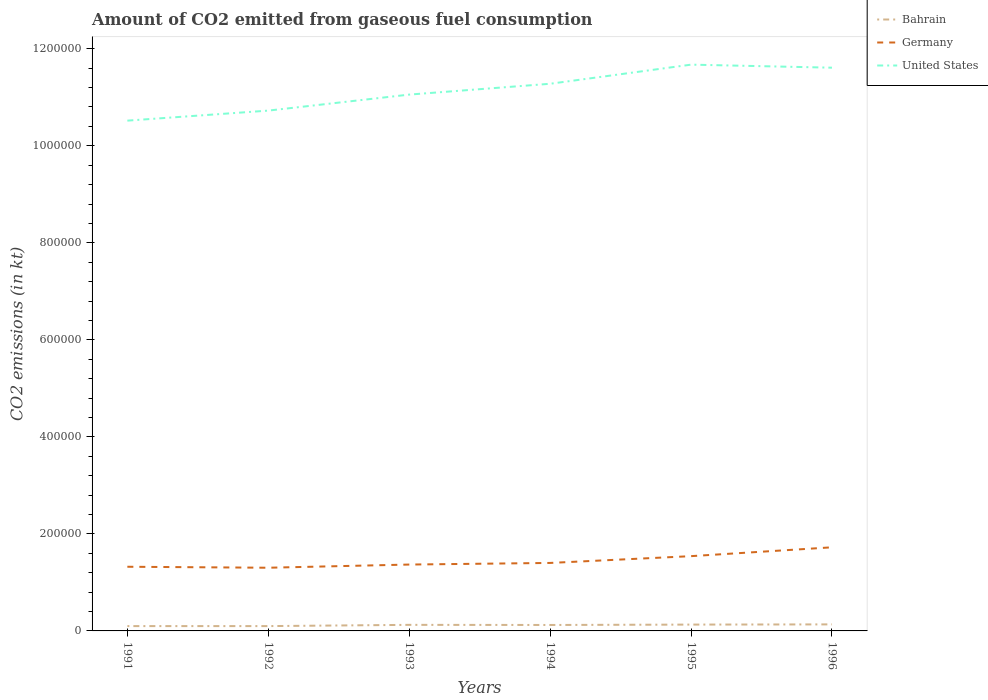Does the line corresponding to Bahrain intersect with the line corresponding to United States?
Offer a terse response. No. Is the number of lines equal to the number of legend labels?
Make the answer very short. Yes. Across all years, what is the maximum amount of CO2 emitted in Germany?
Ensure brevity in your answer.  1.30e+05. In which year was the amount of CO2 emitted in Germany maximum?
Provide a succinct answer. 1992. What is the total amount of CO2 emitted in Germany in the graph?
Make the answer very short. -1.82e+04. What is the difference between the highest and the second highest amount of CO2 emitted in Bahrain?
Provide a succinct answer. 3520.32. What is the difference between two consecutive major ticks on the Y-axis?
Offer a terse response. 2.00e+05. Are the values on the major ticks of Y-axis written in scientific E-notation?
Offer a very short reply. No. Does the graph contain any zero values?
Provide a short and direct response. No. How many legend labels are there?
Give a very brief answer. 3. How are the legend labels stacked?
Your answer should be very brief. Vertical. What is the title of the graph?
Offer a very short reply. Amount of CO2 emitted from gaseous fuel consumption. What is the label or title of the X-axis?
Give a very brief answer. Years. What is the label or title of the Y-axis?
Give a very brief answer. CO2 emissions (in kt). What is the CO2 emissions (in kt) of Bahrain in 1991?
Make the answer very short. 9944.9. What is the CO2 emissions (in kt) in Germany in 1991?
Your answer should be very brief. 1.32e+05. What is the CO2 emissions (in kt) in United States in 1991?
Your response must be concise. 1.05e+06. What is the CO2 emissions (in kt) of Bahrain in 1992?
Ensure brevity in your answer.  9944.9. What is the CO2 emissions (in kt) in Germany in 1992?
Make the answer very short. 1.30e+05. What is the CO2 emissions (in kt) in United States in 1992?
Ensure brevity in your answer.  1.07e+06. What is the CO2 emissions (in kt) in Bahrain in 1993?
Offer a terse response. 1.25e+04. What is the CO2 emissions (in kt) of Germany in 1993?
Your answer should be very brief. 1.37e+05. What is the CO2 emissions (in kt) in United States in 1993?
Give a very brief answer. 1.11e+06. What is the CO2 emissions (in kt) in Bahrain in 1994?
Your answer should be very brief. 1.23e+04. What is the CO2 emissions (in kt) in Germany in 1994?
Provide a succinct answer. 1.40e+05. What is the CO2 emissions (in kt) of United States in 1994?
Make the answer very short. 1.13e+06. What is the CO2 emissions (in kt) in Bahrain in 1995?
Offer a very short reply. 1.31e+04. What is the CO2 emissions (in kt) in Germany in 1995?
Your response must be concise. 1.54e+05. What is the CO2 emissions (in kt) in United States in 1995?
Provide a short and direct response. 1.17e+06. What is the CO2 emissions (in kt) in Bahrain in 1996?
Provide a short and direct response. 1.35e+04. What is the CO2 emissions (in kt) of Germany in 1996?
Your answer should be compact. 1.72e+05. What is the CO2 emissions (in kt) of United States in 1996?
Provide a short and direct response. 1.16e+06. Across all years, what is the maximum CO2 emissions (in kt) of Bahrain?
Your answer should be compact. 1.35e+04. Across all years, what is the maximum CO2 emissions (in kt) in Germany?
Make the answer very short. 1.72e+05. Across all years, what is the maximum CO2 emissions (in kt) in United States?
Your answer should be compact. 1.17e+06. Across all years, what is the minimum CO2 emissions (in kt) in Bahrain?
Offer a very short reply. 9944.9. Across all years, what is the minimum CO2 emissions (in kt) in Germany?
Keep it short and to the point. 1.30e+05. Across all years, what is the minimum CO2 emissions (in kt) of United States?
Offer a terse response. 1.05e+06. What is the total CO2 emissions (in kt) of Bahrain in the graph?
Your answer should be compact. 7.12e+04. What is the total CO2 emissions (in kt) of Germany in the graph?
Keep it short and to the point. 8.66e+05. What is the total CO2 emissions (in kt) of United States in the graph?
Ensure brevity in your answer.  6.69e+06. What is the difference between the CO2 emissions (in kt) in Bahrain in 1991 and that in 1992?
Ensure brevity in your answer.  0. What is the difference between the CO2 emissions (in kt) in Germany in 1991 and that in 1992?
Give a very brief answer. 2020.52. What is the difference between the CO2 emissions (in kt) of United States in 1991 and that in 1992?
Provide a succinct answer. -2.07e+04. What is the difference between the CO2 emissions (in kt) of Bahrain in 1991 and that in 1993?
Offer a terse response. -2574.23. What is the difference between the CO2 emissions (in kt) of Germany in 1991 and that in 1993?
Your response must be concise. -4539.75. What is the difference between the CO2 emissions (in kt) in United States in 1991 and that in 1993?
Provide a succinct answer. -5.37e+04. What is the difference between the CO2 emissions (in kt) in Bahrain in 1991 and that in 1994?
Provide a succinct answer. -2317.54. What is the difference between the CO2 emissions (in kt) in Germany in 1991 and that in 1994?
Provide a short and direct response. -7865.72. What is the difference between the CO2 emissions (in kt) in United States in 1991 and that in 1994?
Give a very brief answer. -7.60e+04. What is the difference between the CO2 emissions (in kt) in Bahrain in 1991 and that in 1995?
Offer a very short reply. -3109.62. What is the difference between the CO2 emissions (in kt) in Germany in 1991 and that in 1995?
Provide a short and direct response. -2.19e+04. What is the difference between the CO2 emissions (in kt) of United States in 1991 and that in 1995?
Give a very brief answer. -1.15e+05. What is the difference between the CO2 emissions (in kt) of Bahrain in 1991 and that in 1996?
Offer a terse response. -3520.32. What is the difference between the CO2 emissions (in kt) of Germany in 1991 and that in 1996?
Keep it short and to the point. -4.01e+04. What is the difference between the CO2 emissions (in kt) of United States in 1991 and that in 1996?
Ensure brevity in your answer.  -1.09e+05. What is the difference between the CO2 emissions (in kt) of Bahrain in 1992 and that in 1993?
Ensure brevity in your answer.  -2574.23. What is the difference between the CO2 emissions (in kt) of Germany in 1992 and that in 1993?
Your response must be concise. -6560.26. What is the difference between the CO2 emissions (in kt) in United States in 1992 and that in 1993?
Give a very brief answer. -3.30e+04. What is the difference between the CO2 emissions (in kt) of Bahrain in 1992 and that in 1994?
Provide a short and direct response. -2317.54. What is the difference between the CO2 emissions (in kt) in Germany in 1992 and that in 1994?
Make the answer very short. -9886.23. What is the difference between the CO2 emissions (in kt) in United States in 1992 and that in 1994?
Ensure brevity in your answer.  -5.53e+04. What is the difference between the CO2 emissions (in kt) of Bahrain in 1992 and that in 1995?
Ensure brevity in your answer.  -3109.62. What is the difference between the CO2 emissions (in kt) of Germany in 1992 and that in 1995?
Make the answer very short. -2.39e+04. What is the difference between the CO2 emissions (in kt) of United States in 1992 and that in 1995?
Offer a very short reply. -9.47e+04. What is the difference between the CO2 emissions (in kt) in Bahrain in 1992 and that in 1996?
Your response must be concise. -3520.32. What is the difference between the CO2 emissions (in kt) of Germany in 1992 and that in 1996?
Your answer should be compact. -4.21e+04. What is the difference between the CO2 emissions (in kt) in United States in 1992 and that in 1996?
Give a very brief answer. -8.85e+04. What is the difference between the CO2 emissions (in kt) of Bahrain in 1993 and that in 1994?
Offer a very short reply. 256.69. What is the difference between the CO2 emissions (in kt) of Germany in 1993 and that in 1994?
Offer a very short reply. -3325.97. What is the difference between the CO2 emissions (in kt) in United States in 1993 and that in 1994?
Your answer should be compact. -2.23e+04. What is the difference between the CO2 emissions (in kt) of Bahrain in 1993 and that in 1995?
Your answer should be very brief. -535.38. What is the difference between the CO2 emissions (in kt) of Germany in 1993 and that in 1995?
Provide a succinct answer. -1.73e+04. What is the difference between the CO2 emissions (in kt) of United States in 1993 and that in 1995?
Provide a succinct answer. -6.17e+04. What is the difference between the CO2 emissions (in kt) in Bahrain in 1993 and that in 1996?
Make the answer very short. -946.09. What is the difference between the CO2 emissions (in kt) of Germany in 1993 and that in 1996?
Your answer should be compact. -3.56e+04. What is the difference between the CO2 emissions (in kt) of United States in 1993 and that in 1996?
Ensure brevity in your answer.  -5.55e+04. What is the difference between the CO2 emissions (in kt) of Bahrain in 1994 and that in 1995?
Offer a terse response. -792.07. What is the difference between the CO2 emissions (in kt) in Germany in 1994 and that in 1995?
Your response must be concise. -1.40e+04. What is the difference between the CO2 emissions (in kt) of United States in 1994 and that in 1995?
Offer a terse response. -3.94e+04. What is the difference between the CO2 emissions (in kt) in Bahrain in 1994 and that in 1996?
Offer a very short reply. -1202.78. What is the difference between the CO2 emissions (in kt) of Germany in 1994 and that in 1996?
Offer a terse response. -3.22e+04. What is the difference between the CO2 emissions (in kt) of United States in 1994 and that in 1996?
Make the answer very short. -3.31e+04. What is the difference between the CO2 emissions (in kt) of Bahrain in 1995 and that in 1996?
Offer a terse response. -410.7. What is the difference between the CO2 emissions (in kt) in Germany in 1995 and that in 1996?
Offer a very short reply. -1.82e+04. What is the difference between the CO2 emissions (in kt) in United States in 1995 and that in 1996?
Give a very brief answer. 6277.9. What is the difference between the CO2 emissions (in kt) in Bahrain in 1991 and the CO2 emissions (in kt) in Germany in 1992?
Provide a succinct answer. -1.20e+05. What is the difference between the CO2 emissions (in kt) of Bahrain in 1991 and the CO2 emissions (in kt) of United States in 1992?
Provide a succinct answer. -1.06e+06. What is the difference between the CO2 emissions (in kt) in Germany in 1991 and the CO2 emissions (in kt) in United States in 1992?
Your response must be concise. -9.40e+05. What is the difference between the CO2 emissions (in kt) of Bahrain in 1991 and the CO2 emissions (in kt) of Germany in 1993?
Ensure brevity in your answer.  -1.27e+05. What is the difference between the CO2 emissions (in kt) in Bahrain in 1991 and the CO2 emissions (in kt) in United States in 1993?
Keep it short and to the point. -1.10e+06. What is the difference between the CO2 emissions (in kt) in Germany in 1991 and the CO2 emissions (in kt) in United States in 1993?
Offer a very short reply. -9.73e+05. What is the difference between the CO2 emissions (in kt) of Bahrain in 1991 and the CO2 emissions (in kt) of Germany in 1994?
Provide a succinct answer. -1.30e+05. What is the difference between the CO2 emissions (in kt) of Bahrain in 1991 and the CO2 emissions (in kt) of United States in 1994?
Provide a short and direct response. -1.12e+06. What is the difference between the CO2 emissions (in kt) in Germany in 1991 and the CO2 emissions (in kt) in United States in 1994?
Make the answer very short. -9.96e+05. What is the difference between the CO2 emissions (in kt) of Bahrain in 1991 and the CO2 emissions (in kt) of Germany in 1995?
Give a very brief answer. -1.44e+05. What is the difference between the CO2 emissions (in kt) in Bahrain in 1991 and the CO2 emissions (in kt) in United States in 1995?
Give a very brief answer. -1.16e+06. What is the difference between the CO2 emissions (in kt) in Germany in 1991 and the CO2 emissions (in kt) in United States in 1995?
Make the answer very short. -1.04e+06. What is the difference between the CO2 emissions (in kt) in Bahrain in 1991 and the CO2 emissions (in kt) in Germany in 1996?
Your answer should be very brief. -1.62e+05. What is the difference between the CO2 emissions (in kt) of Bahrain in 1991 and the CO2 emissions (in kt) of United States in 1996?
Your answer should be compact. -1.15e+06. What is the difference between the CO2 emissions (in kt) of Germany in 1991 and the CO2 emissions (in kt) of United States in 1996?
Offer a very short reply. -1.03e+06. What is the difference between the CO2 emissions (in kt) in Bahrain in 1992 and the CO2 emissions (in kt) in Germany in 1993?
Provide a succinct answer. -1.27e+05. What is the difference between the CO2 emissions (in kt) in Bahrain in 1992 and the CO2 emissions (in kt) in United States in 1993?
Make the answer very short. -1.10e+06. What is the difference between the CO2 emissions (in kt) of Germany in 1992 and the CO2 emissions (in kt) of United States in 1993?
Provide a succinct answer. -9.75e+05. What is the difference between the CO2 emissions (in kt) of Bahrain in 1992 and the CO2 emissions (in kt) of Germany in 1994?
Keep it short and to the point. -1.30e+05. What is the difference between the CO2 emissions (in kt) in Bahrain in 1992 and the CO2 emissions (in kt) in United States in 1994?
Provide a succinct answer. -1.12e+06. What is the difference between the CO2 emissions (in kt) of Germany in 1992 and the CO2 emissions (in kt) of United States in 1994?
Ensure brevity in your answer.  -9.98e+05. What is the difference between the CO2 emissions (in kt) in Bahrain in 1992 and the CO2 emissions (in kt) in Germany in 1995?
Provide a succinct answer. -1.44e+05. What is the difference between the CO2 emissions (in kt) of Bahrain in 1992 and the CO2 emissions (in kt) of United States in 1995?
Your answer should be very brief. -1.16e+06. What is the difference between the CO2 emissions (in kt) of Germany in 1992 and the CO2 emissions (in kt) of United States in 1995?
Ensure brevity in your answer.  -1.04e+06. What is the difference between the CO2 emissions (in kt) of Bahrain in 1992 and the CO2 emissions (in kt) of Germany in 1996?
Keep it short and to the point. -1.62e+05. What is the difference between the CO2 emissions (in kt) of Bahrain in 1992 and the CO2 emissions (in kt) of United States in 1996?
Keep it short and to the point. -1.15e+06. What is the difference between the CO2 emissions (in kt) of Germany in 1992 and the CO2 emissions (in kt) of United States in 1996?
Offer a terse response. -1.03e+06. What is the difference between the CO2 emissions (in kt) in Bahrain in 1993 and the CO2 emissions (in kt) in Germany in 1994?
Ensure brevity in your answer.  -1.28e+05. What is the difference between the CO2 emissions (in kt) of Bahrain in 1993 and the CO2 emissions (in kt) of United States in 1994?
Provide a succinct answer. -1.12e+06. What is the difference between the CO2 emissions (in kt) in Germany in 1993 and the CO2 emissions (in kt) in United States in 1994?
Keep it short and to the point. -9.91e+05. What is the difference between the CO2 emissions (in kt) in Bahrain in 1993 and the CO2 emissions (in kt) in Germany in 1995?
Ensure brevity in your answer.  -1.42e+05. What is the difference between the CO2 emissions (in kt) in Bahrain in 1993 and the CO2 emissions (in kt) in United States in 1995?
Your response must be concise. -1.15e+06. What is the difference between the CO2 emissions (in kt) in Germany in 1993 and the CO2 emissions (in kt) in United States in 1995?
Ensure brevity in your answer.  -1.03e+06. What is the difference between the CO2 emissions (in kt) in Bahrain in 1993 and the CO2 emissions (in kt) in Germany in 1996?
Make the answer very short. -1.60e+05. What is the difference between the CO2 emissions (in kt) in Bahrain in 1993 and the CO2 emissions (in kt) in United States in 1996?
Ensure brevity in your answer.  -1.15e+06. What is the difference between the CO2 emissions (in kt) of Germany in 1993 and the CO2 emissions (in kt) of United States in 1996?
Offer a terse response. -1.02e+06. What is the difference between the CO2 emissions (in kt) of Bahrain in 1994 and the CO2 emissions (in kt) of Germany in 1995?
Keep it short and to the point. -1.42e+05. What is the difference between the CO2 emissions (in kt) in Bahrain in 1994 and the CO2 emissions (in kt) in United States in 1995?
Ensure brevity in your answer.  -1.16e+06. What is the difference between the CO2 emissions (in kt) in Germany in 1994 and the CO2 emissions (in kt) in United States in 1995?
Provide a succinct answer. -1.03e+06. What is the difference between the CO2 emissions (in kt) in Bahrain in 1994 and the CO2 emissions (in kt) in Germany in 1996?
Your answer should be very brief. -1.60e+05. What is the difference between the CO2 emissions (in kt) in Bahrain in 1994 and the CO2 emissions (in kt) in United States in 1996?
Ensure brevity in your answer.  -1.15e+06. What is the difference between the CO2 emissions (in kt) of Germany in 1994 and the CO2 emissions (in kt) of United States in 1996?
Keep it short and to the point. -1.02e+06. What is the difference between the CO2 emissions (in kt) in Bahrain in 1995 and the CO2 emissions (in kt) in Germany in 1996?
Your answer should be compact. -1.59e+05. What is the difference between the CO2 emissions (in kt) in Bahrain in 1995 and the CO2 emissions (in kt) in United States in 1996?
Provide a succinct answer. -1.15e+06. What is the difference between the CO2 emissions (in kt) of Germany in 1995 and the CO2 emissions (in kt) of United States in 1996?
Your answer should be very brief. -1.01e+06. What is the average CO2 emissions (in kt) of Bahrain per year?
Provide a succinct answer. 1.19e+04. What is the average CO2 emissions (in kt) of Germany per year?
Keep it short and to the point. 1.44e+05. What is the average CO2 emissions (in kt) of United States per year?
Your response must be concise. 1.11e+06. In the year 1991, what is the difference between the CO2 emissions (in kt) of Bahrain and CO2 emissions (in kt) of Germany?
Your response must be concise. -1.22e+05. In the year 1991, what is the difference between the CO2 emissions (in kt) of Bahrain and CO2 emissions (in kt) of United States?
Provide a succinct answer. -1.04e+06. In the year 1991, what is the difference between the CO2 emissions (in kt) in Germany and CO2 emissions (in kt) in United States?
Offer a very short reply. -9.20e+05. In the year 1992, what is the difference between the CO2 emissions (in kt) of Bahrain and CO2 emissions (in kt) of Germany?
Your answer should be compact. -1.20e+05. In the year 1992, what is the difference between the CO2 emissions (in kt) in Bahrain and CO2 emissions (in kt) in United States?
Your answer should be compact. -1.06e+06. In the year 1992, what is the difference between the CO2 emissions (in kt) of Germany and CO2 emissions (in kt) of United States?
Your answer should be compact. -9.42e+05. In the year 1993, what is the difference between the CO2 emissions (in kt) of Bahrain and CO2 emissions (in kt) of Germany?
Keep it short and to the point. -1.24e+05. In the year 1993, what is the difference between the CO2 emissions (in kt) in Bahrain and CO2 emissions (in kt) in United States?
Your response must be concise. -1.09e+06. In the year 1993, what is the difference between the CO2 emissions (in kt) in Germany and CO2 emissions (in kt) in United States?
Offer a terse response. -9.69e+05. In the year 1994, what is the difference between the CO2 emissions (in kt) of Bahrain and CO2 emissions (in kt) of Germany?
Give a very brief answer. -1.28e+05. In the year 1994, what is the difference between the CO2 emissions (in kt) of Bahrain and CO2 emissions (in kt) of United States?
Your answer should be compact. -1.12e+06. In the year 1994, what is the difference between the CO2 emissions (in kt) of Germany and CO2 emissions (in kt) of United States?
Make the answer very short. -9.88e+05. In the year 1995, what is the difference between the CO2 emissions (in kt) in Bahrain and CO2 emissions (in kt) in Germany?
Provide a succinct answer. -1.41e+05. In the year 1995, what is the difference between the CO2 emissions (in kt) of Bahrain and CO2 emissions (in kt) of United States?
Your response must be concise. -1.15e+06. In the year 1995, what is the difference between the CO2 emissions (in kt) of Germany and CO2 emissions (in kt) of United States?
Offer a terse response. -1.01e+06. In the year 1996, what is the difference between the CO2 emissions (in kt) of Bahrain and CO2 emissions (in kt) of Germany?
Give a very brief answer. -1.59e+05. In the year 1996, what is the difference between the CO2 emissions (in kt) in Bahrain and CO2 emissions (in kt) in United States?
Your answer should be compact. -1.15e+06. In the year 1996, what is the difference between the CO2 emissions (in kt) of Germany and CO2 emissions (in kt) of United States?
Offer a very short reply. -9.89e+05. What is the ratio of the CO2 emissions (in kt) in Bahrain in 1991 to that in 1992?
Make the answer very short. 1. What is the ratio of the CO2 emissions (in kt) of Germany in 1991 to that in 1992?
Offer a terse response. 1.02. What is the ratio of the CO2 emissions (in kt) of United States in 1991 to that in 1992?
Make the answer very short. 0.98. What is the ratio of the CO2 emissions (in kt) of Bahrain in 1991 to that in 1993?
Offer a terse response. 0.79. What is the ratio of the CO2 emissions (in kt) of Germany in 1991 to that in 1993?
Your answer should be compact. 0.97. What is the ratio of the CO2 emissions (in kt) of United States in 1991 to that in 1993?
Give a very brief answer. 0.95. What is the ratio of the CO2 emissions (in kt) of Bahrain in 1991 to that in 1994?
Provide a succinct answer. 0.81. What is the ratio of the CO2 emissions (in kt) in Germany in 1991 to that in 1994?
Give a very brief answer. 0.94. What is the ratio of the CO2 emissions (in kt) in United States in 1991 to that in 1994?
Provide a short and direct response. 0.93. What is the ratio of the CO2 emissions (in kt) of Bahrain in 1991 to that in 1995?
Offer a very short reply. 0.76. What is the ratio of the CO2 emissions (in kt) of Germany in 1991 to that in 1995?
Your answer should be very brief. 0.86. What is the ratio of the CO2 emissions (in kt) of United States in 1991 to that in 1995?
Keep it short and to the point. 0.9. What is the ratio of the CO2 emissions (in kt) of Bahrain in 1991 to that in 1996?
Provide a short and direct response. 0.74. What is the ratio of the CO2 emissions (in kt) of Germany in 1991 to that in 1996?
Ensure brevity in your answer.  0.77. What is the ratio of the CO2 emissions (in kt) in United States in 1991 to that in 1996?
Offer a terse response. 0.91. What is the ratio of the CO2 emissions (in kt) in Bahrain in 1992 to that in 1993?
Provide a succinct answer. 0.79. What is the ratio of the CO2 emissions (in kt) in Germany in 1992 to that in 1993?
Your answer should be compact. 0.95. What is the ratio of the CO2 emissions (in kt) in United States in 1992 to that in 1993?
Offer a very short reply. 0.97. What is the ratio of the CO2 emissions (in kt) of Bahrain in 1992 to that in 1994?
Ensure brevity in your answer.  0.81. What is the ratio of the CO2 emissions (in kt) of Germany in 1992 to that in 1994?
Provide a succinct answer. 0.93. What is the ratio of the CO2 emissions (in kt) in United States in 1992 to that in 1994?
Offer a terse response. 0.95. What is the ratio of the CO2 emissions (in kt) of Bahrain in 1992 to that in 1995?
Your answer should be very brief. 0.76. What is the ratio of the CO2 emissions (in kt) in Germany in 1992 to that in 1995?
Give a very brief answer. 0.85. What is the ratio of the CO2 emissions (in kt) in United States in 1992 to that in 1995?
Keep it short and to the point. 0.92. What is the ratio of the CO2 emissions (in kt) in Bahrain in 1992 to that in 1996?
Give a very brief answer. 0.74. What is the ratio of the CO2 emissions (in kt) in Germany in 1992 to that in 1996?
Make the answer very short. 0.76. What is the ratio of the CO2 emissions (in kt) of United States in 1992 to that in 1996?
Your answer should be very brief. 0.92. What is the ratio of the CO2 emissions (in kt) in Bahrain in 1993 to that in 1994?
Your answer should be compact. 1.02. What is the ratio of the CO2 emissions (in kt) in Germany in 1993 to that in 1994?
Make the answer very short. 0.98. What is the ratio of the CO2 emissions (in kt) of United States in 1993 to that in 1994?
Keep it short and to the point. 0.98. What is the ratio of the CO2 emissions (in kt) of Bahrain in 1993 to that in 1995?
Make the answer very short. 0.96. What is the ratio of the CO2 emissions (in kt) of Germany in 1993 to that in 1995?
Give a very brief answer. 0.89. What is the ratio of the CO2 emissions (in kt) of United States in 1993 to that in 1995?
Make the answer very short. 0.95. What is the ratio of the CO2 emissions (in kt) of Bahrain in 1993 to that in 1996?
Your response must be concise. 0.93. What is the ratio of the CO2 emissions (in kt) of Germany in 1993 to that in 1996?
Offer a terse response. 0.79. What is the ratio of the CO2 emissions (in kt) in United States in 1993 to that in 1996?
Provide a succinct answer. 0.95. What is the ratio of the CO2 emissions (in kt) of Bahrain in 1994 to that in 1995?
Your answer should be compact. 0.94. What is the ratio of the CO2 emissions (in kt) in Germany in 1994 to that in 1995?
Offer a very short reply. 0.91. What is the ratio of the CO2 emissions (in kt) in United States in 1994 to that in 1995?
Ensure brevity in your answer.  0.97. What is the ratio of the CO2 emissions (in kt) in Bahrain in 1994 to that in 1996?
Ensure brevity in your answer.  0.91. What is the ratio of the CO2 emissions (in kt) in Germany in 1994 to that in 1996?
Offer a terse response. 0.81. What is the ratio of the CO2 emissions (in kt) in United States in 1994 to that in 1996?
Offer a very short reply. 0.97. What is the ratio of the CO2 emissions (in kt) in Bahrain in 1995 to that in 1996?
Make the answer very short. 0.97. What is the ratio of the CO2 emissions (in kt) in Germany in 1995 to that in 1996?
Your answer should be very brief. 0.89. What is the ratio of the CO2 emissions (in kt) in United States in 1995 to that in 1996?
Your response must be concise. 1.01. What is the difference between the highest and the second highest CO2 emissions (in kt) in Bahrain?
Keep it short and to the point. 410.7. What is the difference between the highest and the second highest CO2 emissions (in kt) in Germany?
Offer a terse response. 1.82e+04. What is the difference between the highest and the second highest CO2 emissions (in kt) of United States?
Make the answer very short. 6277.9. What is the difference between the highest and the lowest CO2 emissions (in kt) in Bahrain?
Keep it short and to the point. 3520.32. What is the difference between the highest and the lowest CO2 emissions (in kt) in Germany?
Make the answer very short. 4.21e+04. What is the difference between the highest and the lowest CO2 emissions (in kt) in United States?
Make the answer very short. 1.15e+05. 